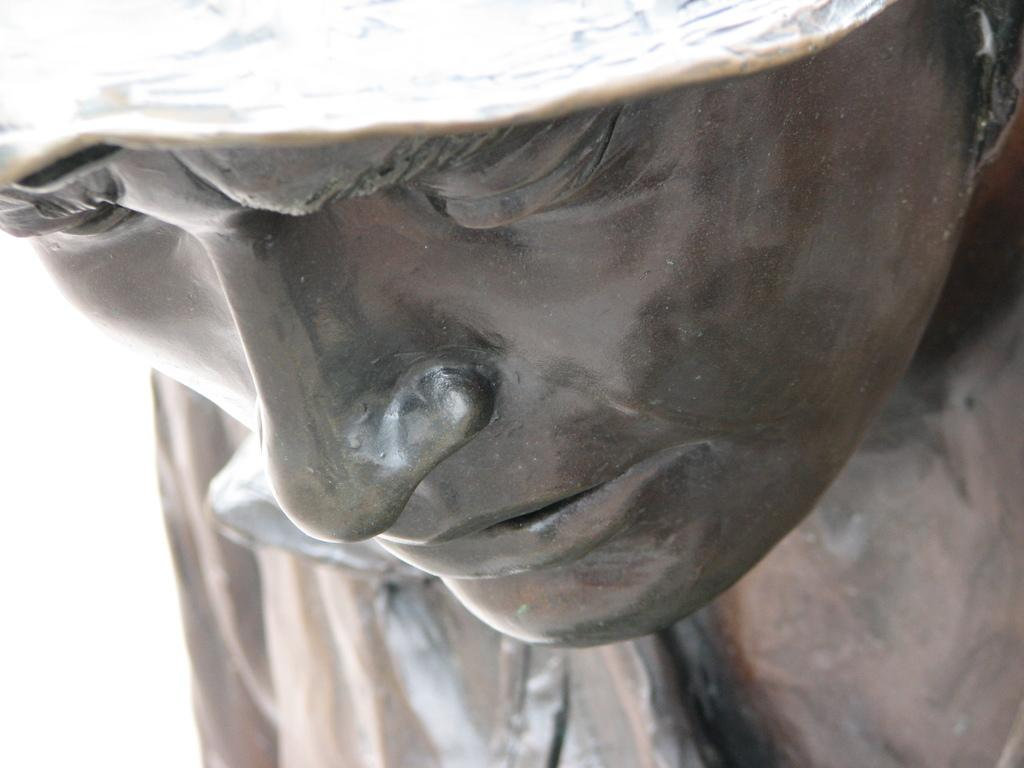What is the main subject of the image? There is a sculpture in the image. What grade is the volleyball player holding in the image? There is no volleyball player or grade present in the image; it features a sculpture. What type of bucket is used to create the sculpture in the image? There is no bucket or indication of the materials used to create the sculpture in the image. 